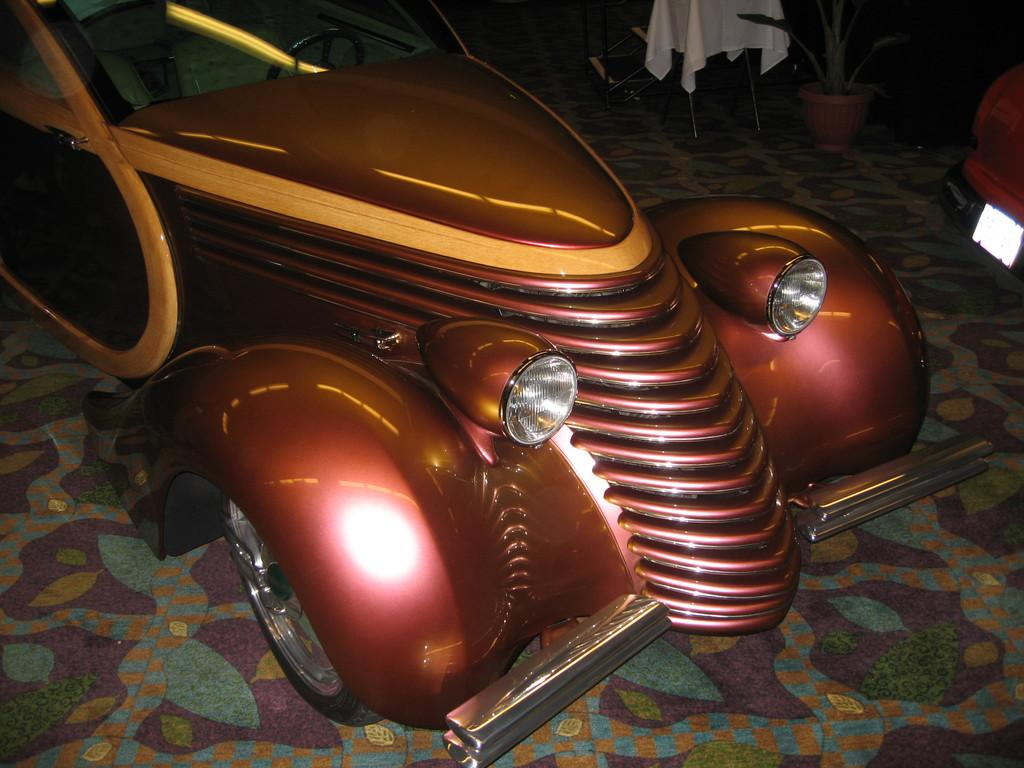What is located on the floor in the foreground of the image? There is a car on the floor in the foreground of the image. What else can be seen on the right side of the image? There appears to be a vehicle on the right side of the image. What type of plant is in a pot in the image? There is a potted plant visible at the top of the image. What is on a chair in the image? There is a white cloth on a chair in the image. How does the car turn into a volleyball in the image? The car does not turn into a volleyball in the image; it remains a car on the floor. What type of ornament is hanging from the potted plant in the image? There is no ornament hanging from the potted plant in the image; only the plant is present. 